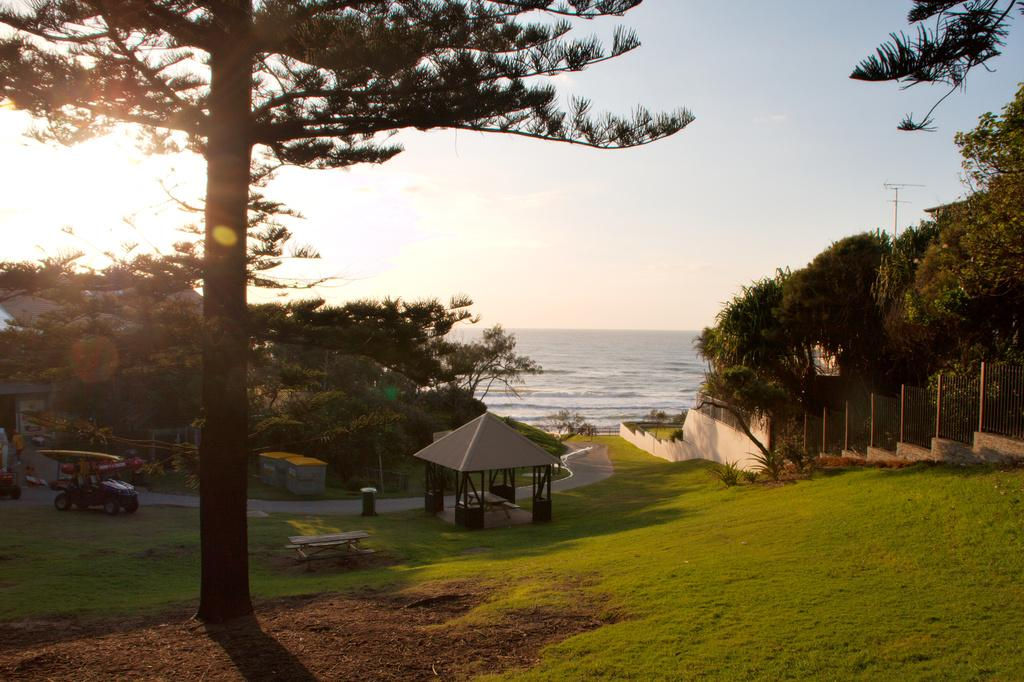What type of vegetation can be seen in the image? There are trees in the image. What type of structure is present in the image? There is a shed in the image. What is located on the left side of the image? There is a vehicle on the left side of the image. What can be seen in the background of the image? Water and the sky are visible in the background of the image. What type of error can be seen in the verse written on the shed in the image? There is no verse or writing on the shed in the image, so there is no error to be seen. 